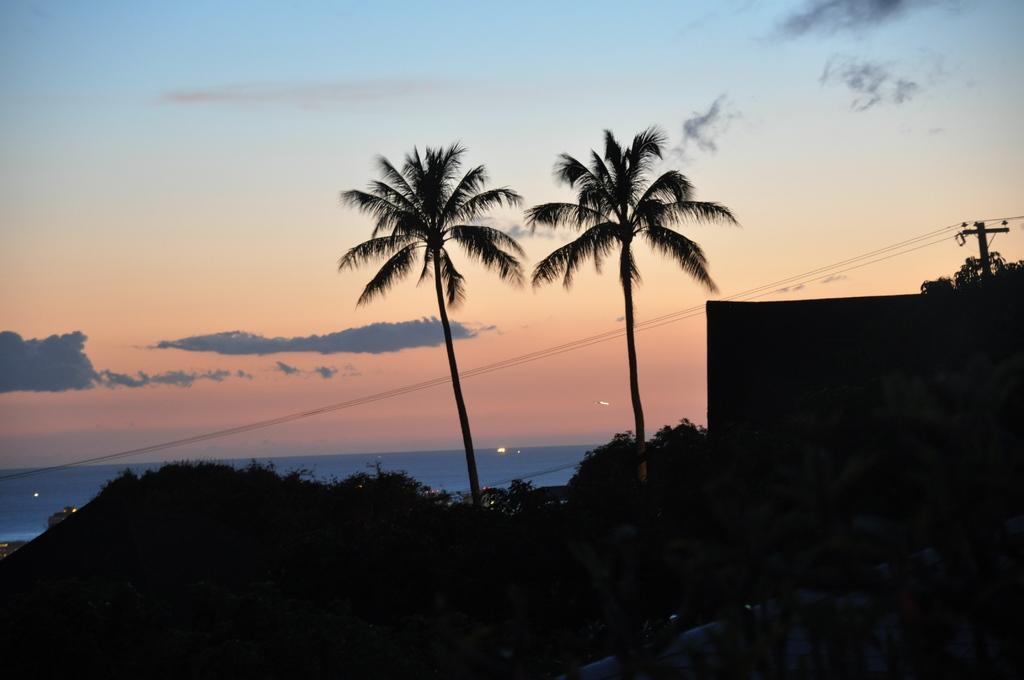What type of vegetation is present in the image? There are trees in the image. What type of structure can be seen in the image? There is a building in the image. What is attached to the pole in the image? The pole has wires attached to it. What is visible in the background of the image? The sky is visible in the background of the image. Can you see a lamp hanging from the tree in the image? There is no lamp hanging from the tree in the image. Is there a pig present in the image? There is no pig present in the image. 